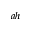<formula> <loc_0><loc_0><loc_500><loc_500>^ { a h }</formula> 